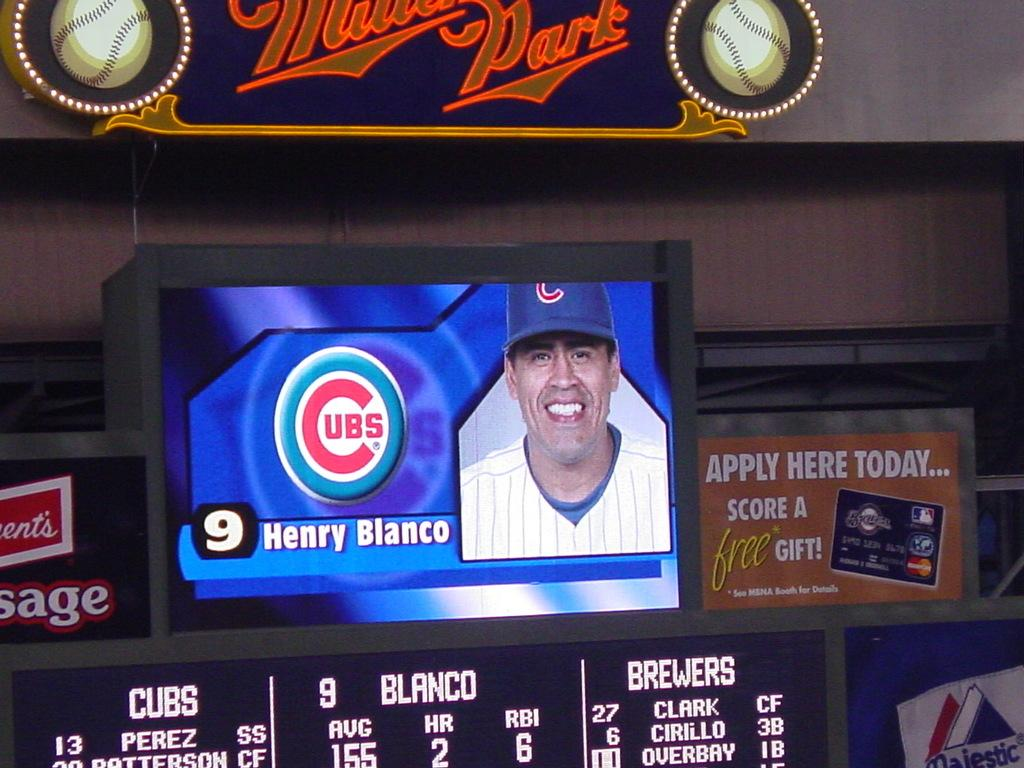<image>
Write a terse but informative summary of the picture. A tv with the picture of a baseball player and the word Cub in red. 